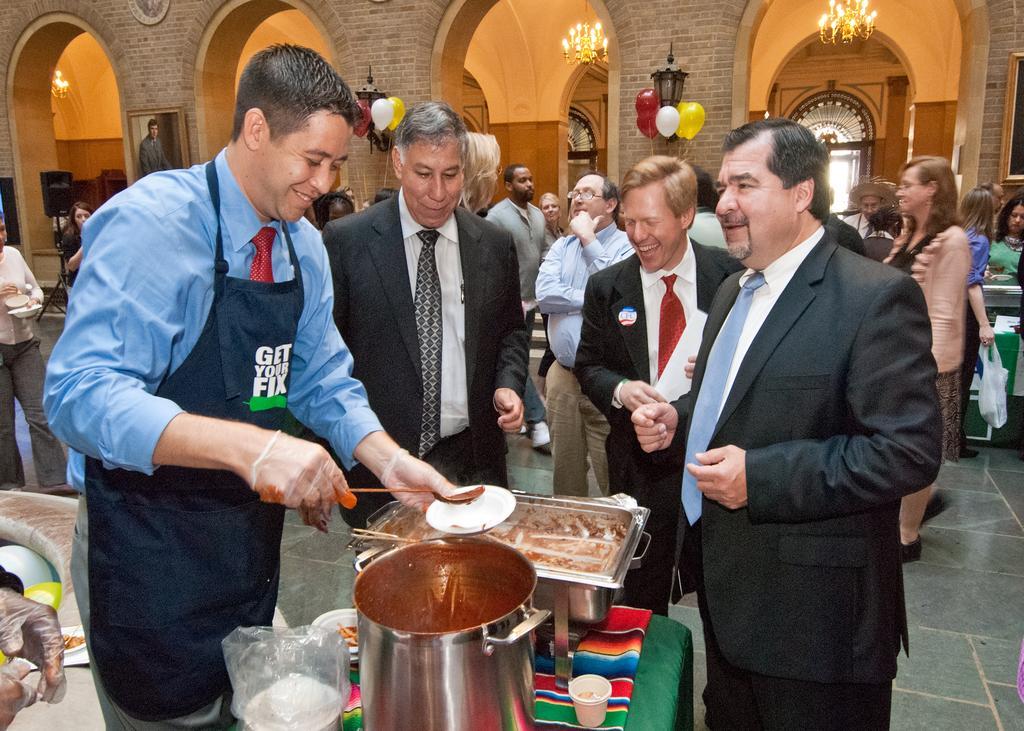Please provide a concise description of this image. In this image, there is a table on that table there is a steel container and there is a man standing and he is holding a spoon and a white color plate, we can see some people standing, in the background we can see some balloons and there are some lights and some pillars. 